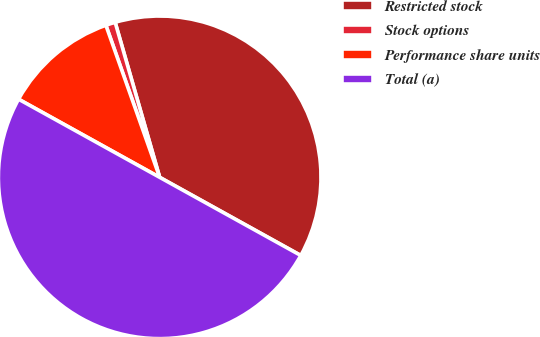Convert chart. <chart><loc_0><loc_0><loc_500><loc_500><pie_chart><fcel>Restricted stock<fcel>Stock options<fcel>Performance share units<fcel>Total (a)<nl><fcel>37.5%<fcel>0.96%<fcel>11.54%<fcel>50.0%<nl></chart> 